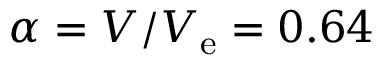Convert formula to latex. <formula><loc_0><loc_0><loc_500><loc_500>\alpha = V / V _ { e } = 0 . 6 4</formula> 